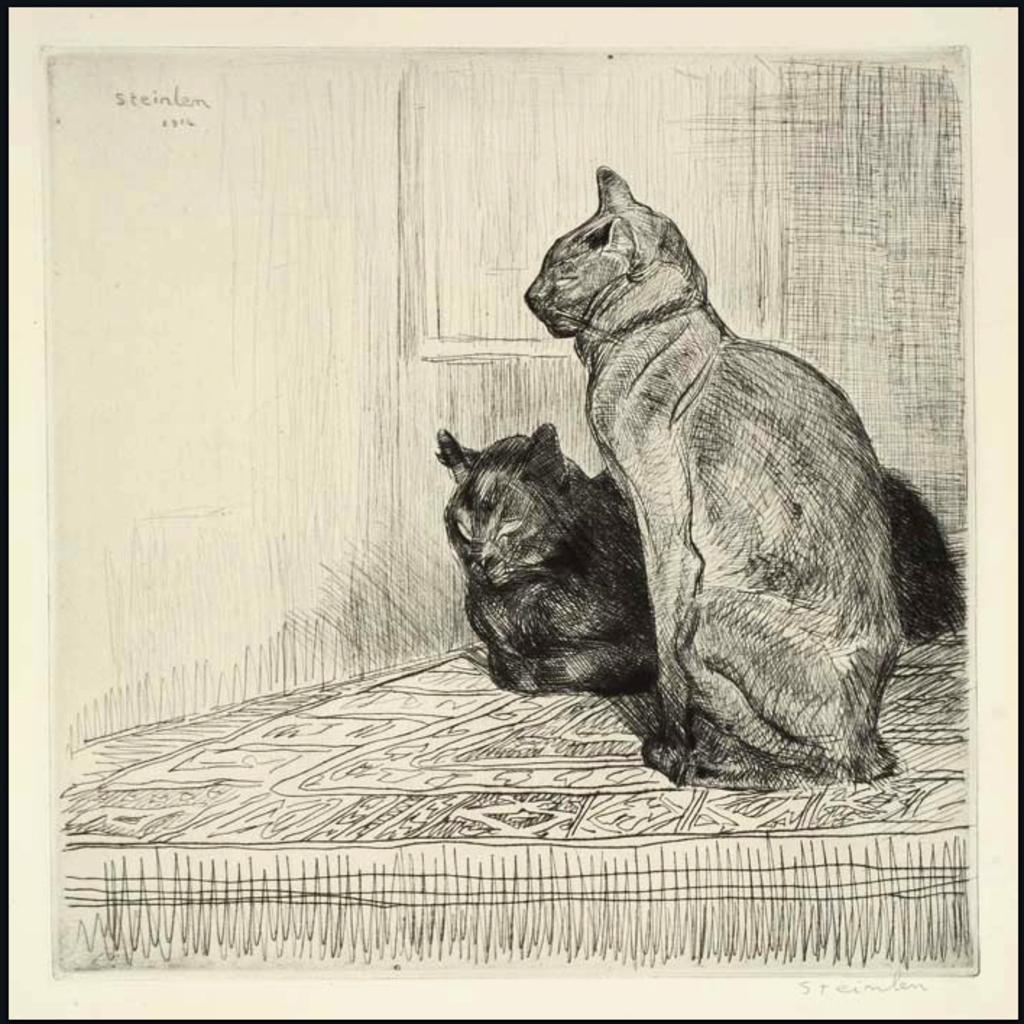What is the main subject of the drawing in the image? The drawing features cats on a platform. What can be seen in the background of the image? There is a wall in the background of the image. Is there any text visible in the image? Yes, there is some text visible in the top left corner of the image. How many metal visitors are present in the image? There are no metal visitors present in the image; it features a drawing of cats on a platform and a wall in the background. 